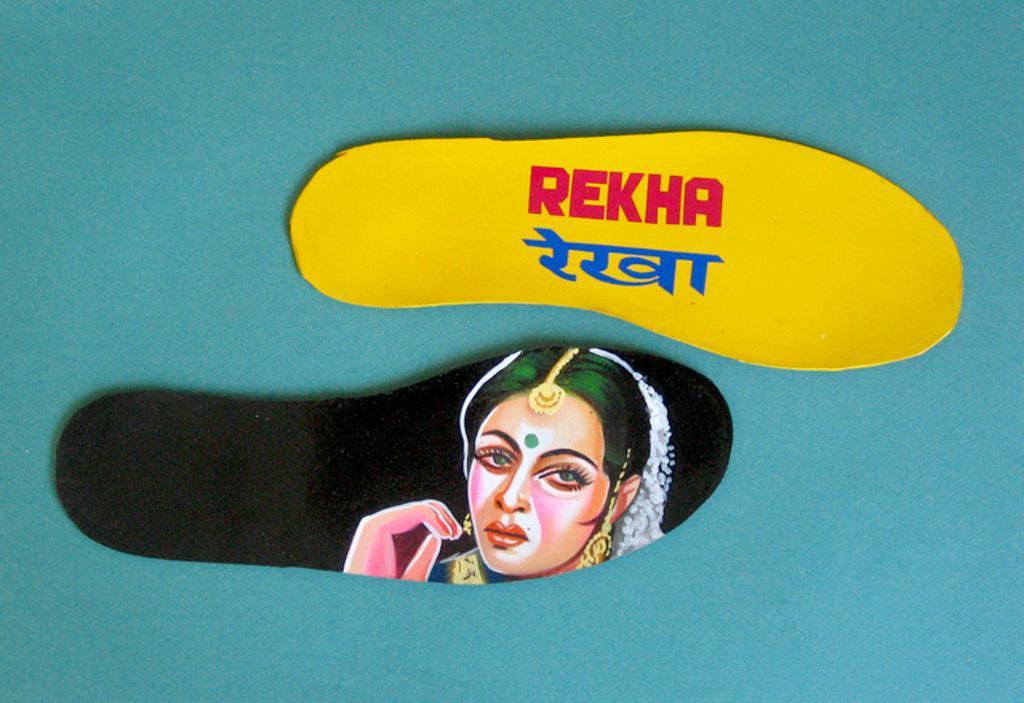Describe this image in one or two sentences. In this image we can see a group of shoe soles with some text printed on them. 